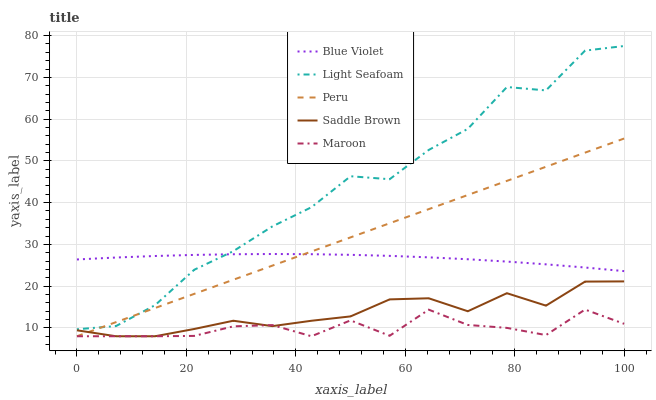Does Maroon have the minimum area under the curve?
Answer yes or no. Yes. Does Light Seafoam have the maximum area under the curve?
Answer yes or no. Yes. Does Peru have the minimum area under the curve?
Answer yes or no. No. Does Peru have the maximum area under the curve?
Answer yes or no. No. Is Peru the smoothest?
Answer yes or no. Yes. Is Light Seafoam the roughest?
Answer yes or no. Yes. Is Light Seafoam the smoothest?
Answer yes or no. No. Is Peru the roughest?
Answer yes or no. No. Does Maroon have the lowest value?
Answer yes or no. Yes. Does Light Seafoam have the lowest value?
Answer yes or no. No. Does Light Seafoam have the highest value?
Answer yes or no. Yes. Does Peru have the highest value?
Answer yes or no. No. Is Maroon less than Light Seafoam?
Answer yes or no. Yes. Is Light Seafoam greater than Saddle Brown?
Answer yes or no. Yes. Does Maroon intersect Peru?
Answer yes or no. Yes. Is Maroon less than Peru?
Answer yes or no. No. Is Maroon greater than Peru?
Answer yes or no. No. Does Maroon intersect Light Seafoam?
Answer yes or no. No. 